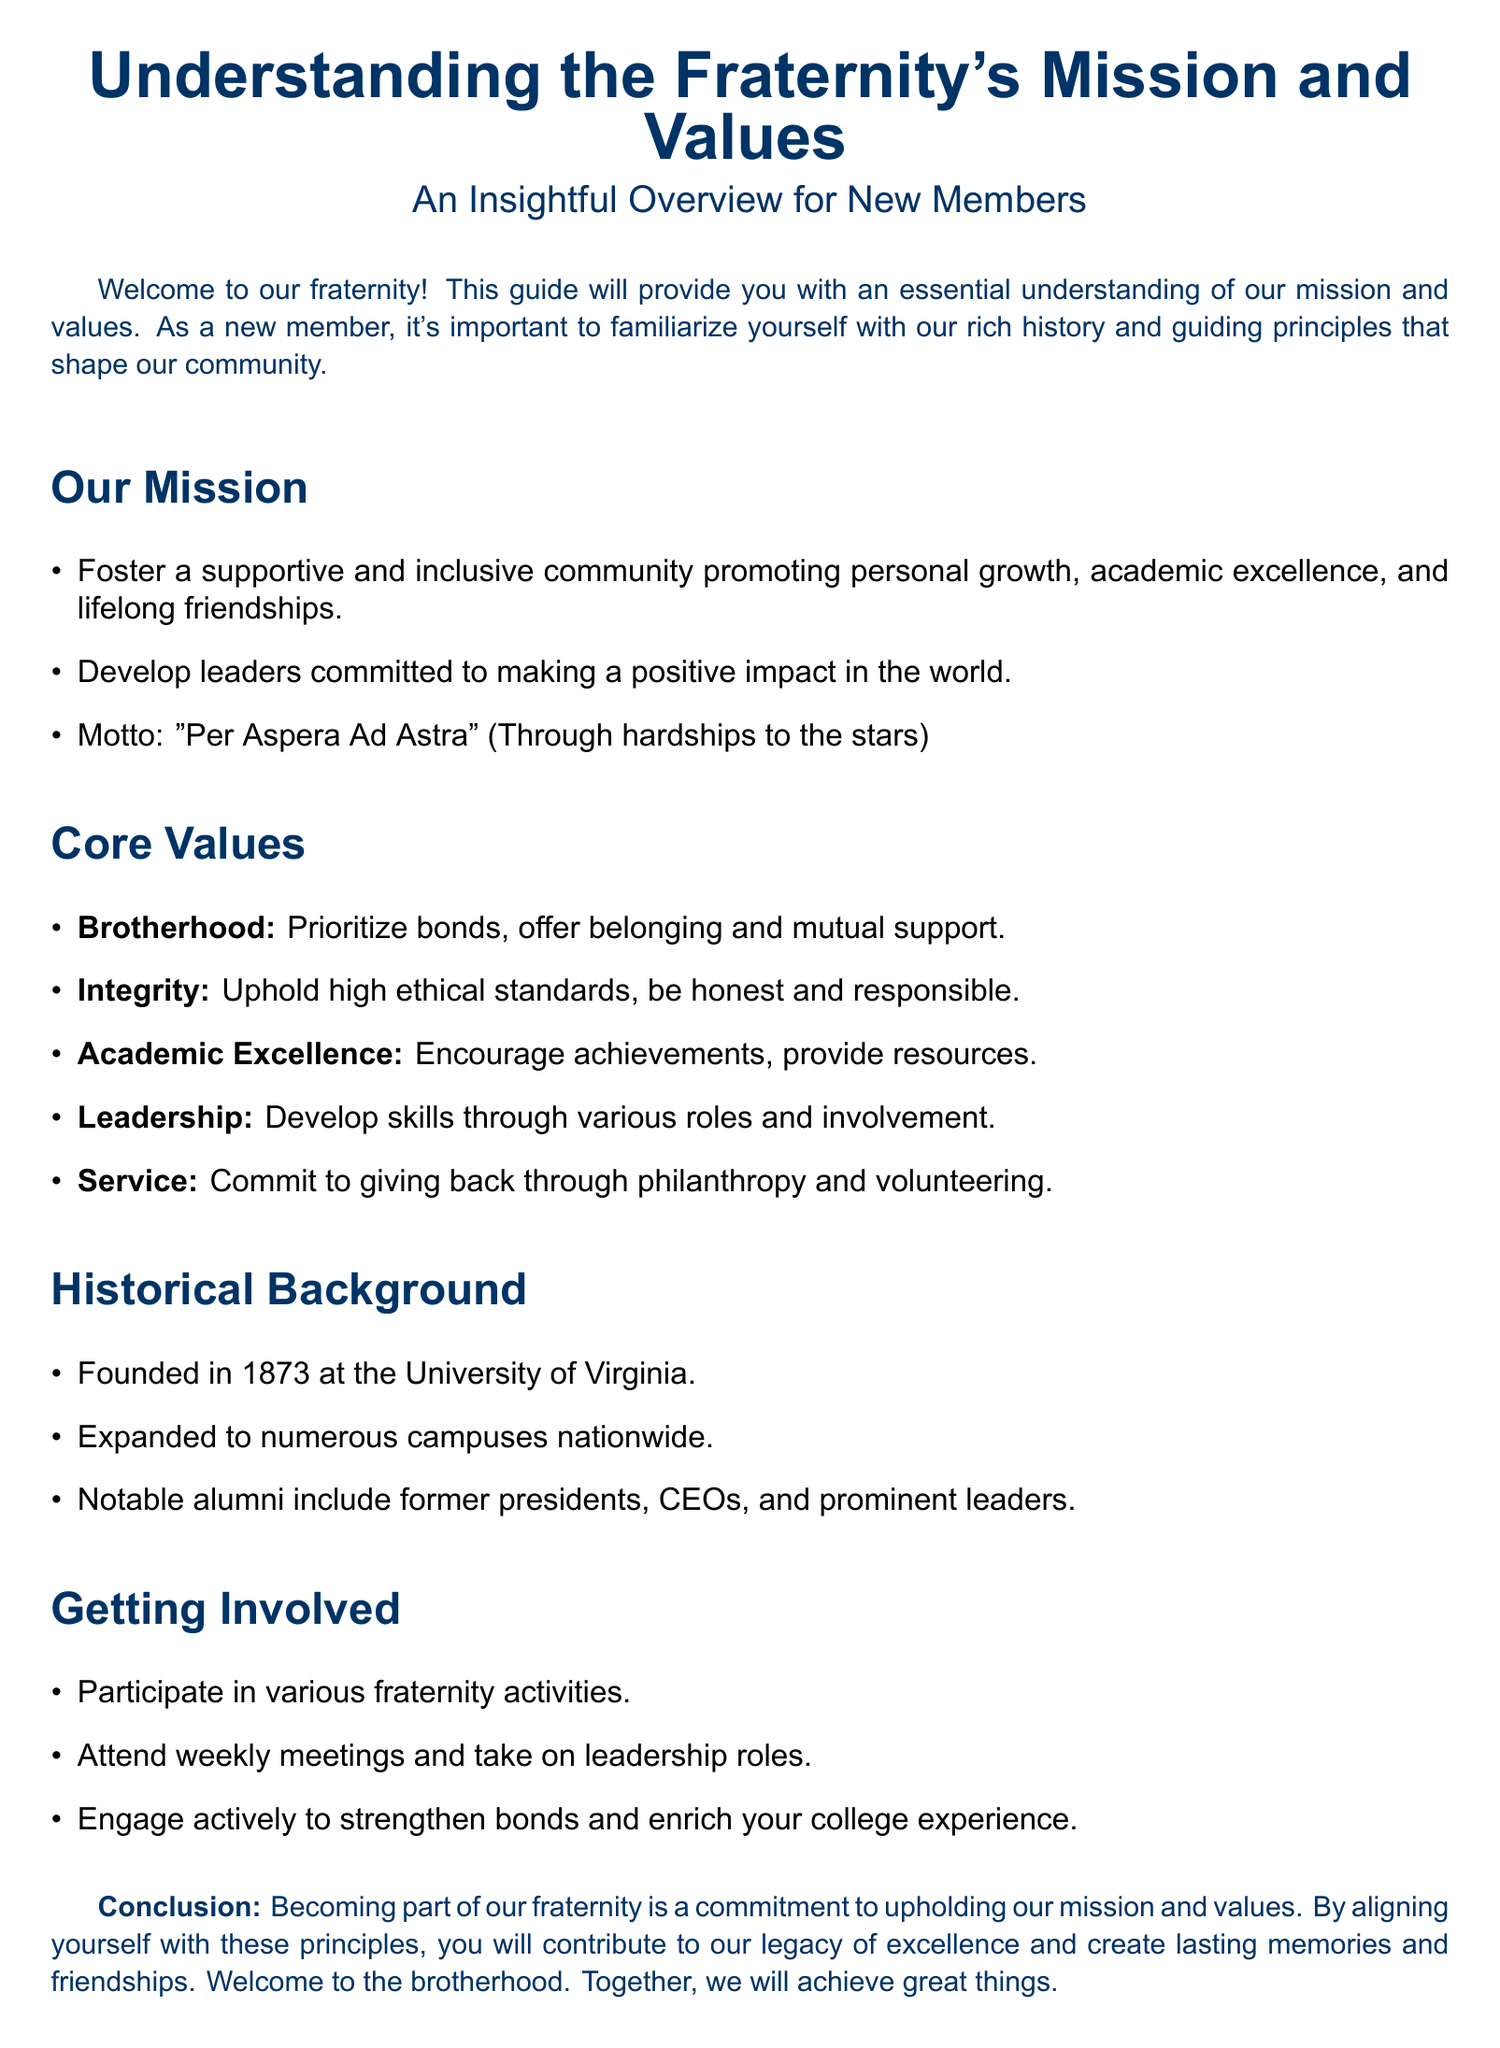What year was the fraternity founded? The founding year is stated in the historical background section of the document.
Answer: 1873 What is the fraternity's motto? The motto is mentioned under the mission section.
Answer: "Per Aspera Ad Astra" Name one core value of the fraternity. The document lists several core values under the core values section.
Answer: Brotherhood What is the fraternity's commitment to community service? The section on core values specifically mentions the fraternity's focus on service.
Answer: Commit to giving back through philanthropy and volunteering How many key areas are outlined under core values? The core values section contains a specific number of listed values.
Answer: Five What is the purpose of participating in fraternity activities according to the document? The document explains the benefits of participation in the getting involved section.
Answer: Strengthen bonds and enrich your college experience Name one notable category of alumni from the fraternity. The historical background section provides information on notable alumni.
Answer: Former presidents What does the term "academic excellence" refer to in the core values? The definition provided in the core values section explains the fraternity's perspective on academic achievement.
Answer: Encourage achievements, provide resources 